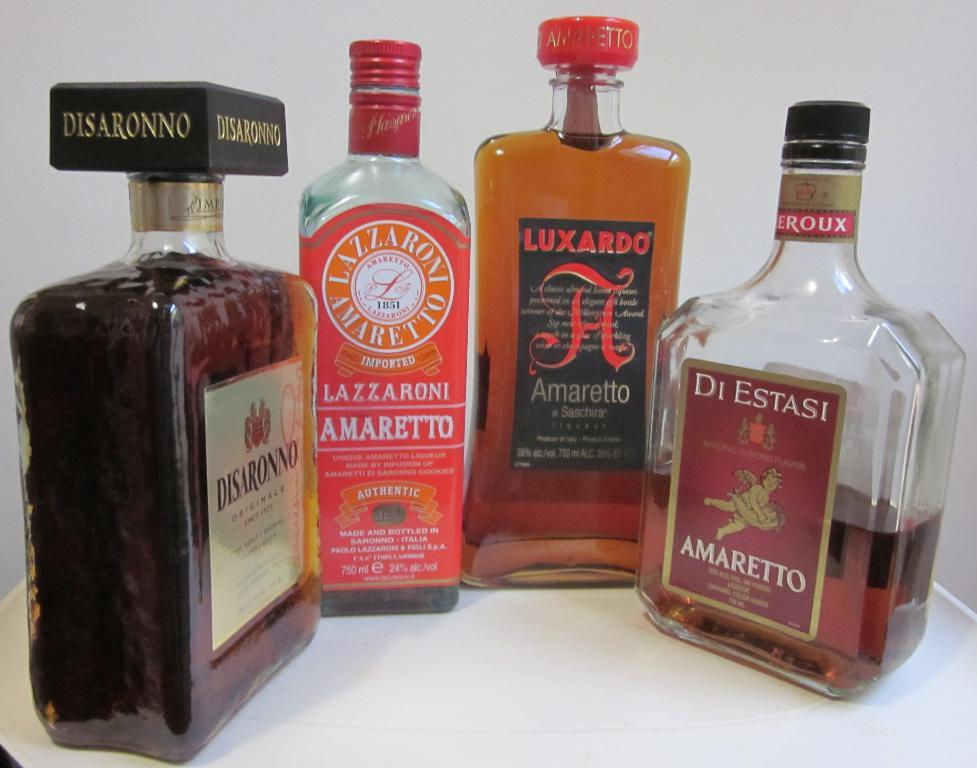Provide a one-sentence caption for the provided image. Four different brands of amaretto are arranged together in a semi-circle. 